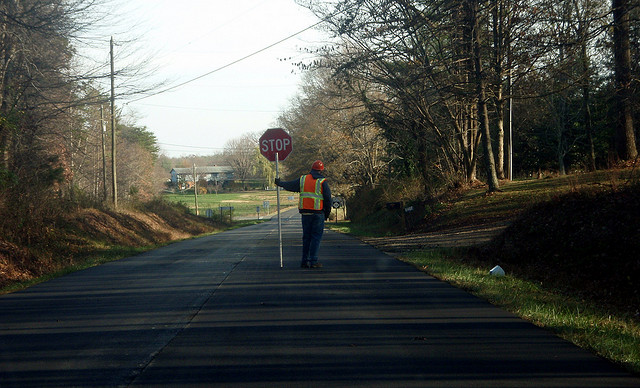Please extract the text content from this image. STOP 